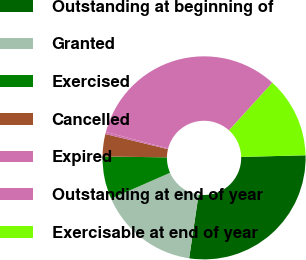Convert chart. <chart><loc_0><loc_0><loc_500><loc_500><pie_chart><fcel>Outstanding at beginning of<fcel>Granted<fcel>Exercised<fcel>Cancelled<fcel>Expired<fcel>Outstanding at end of year<fcel>Exercisable at end of year<nl><fcel>27.76%<fcel>16.08%<fcel>6.79%<fcel>3.56%<fcel>0.33%<fcel>32.64%<fcel>12.85%<nl></chart> 